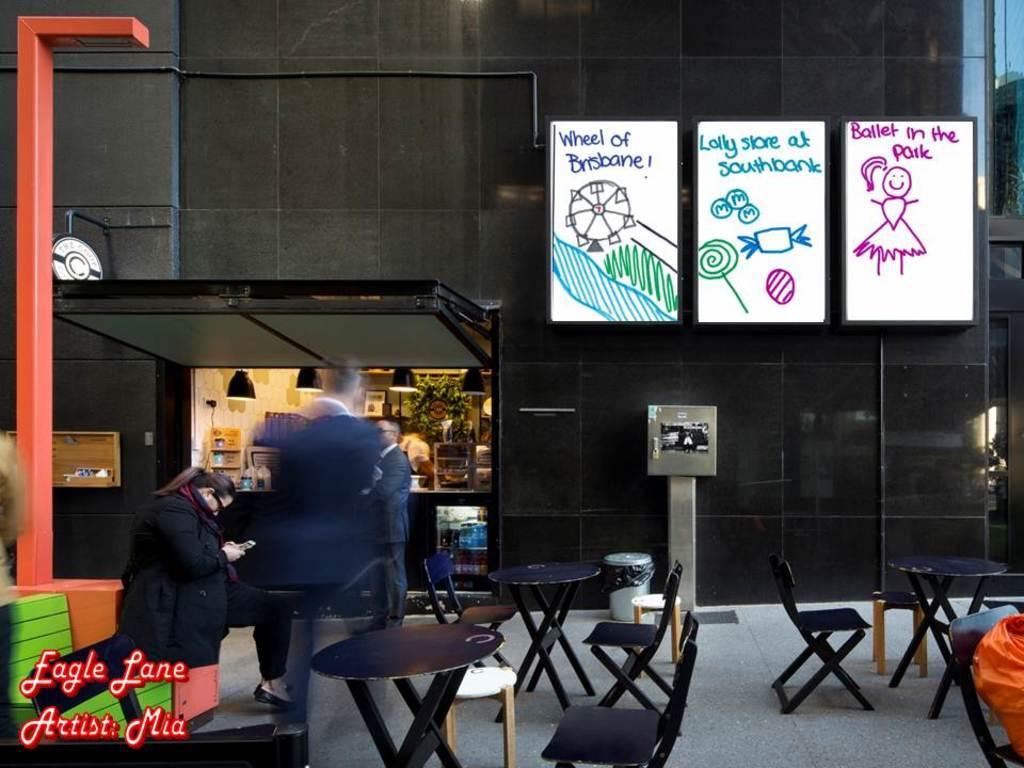Please provide a concise description of this image. there is a restaurant and food ordering place behind that there is a tables and shares and few people standing. 